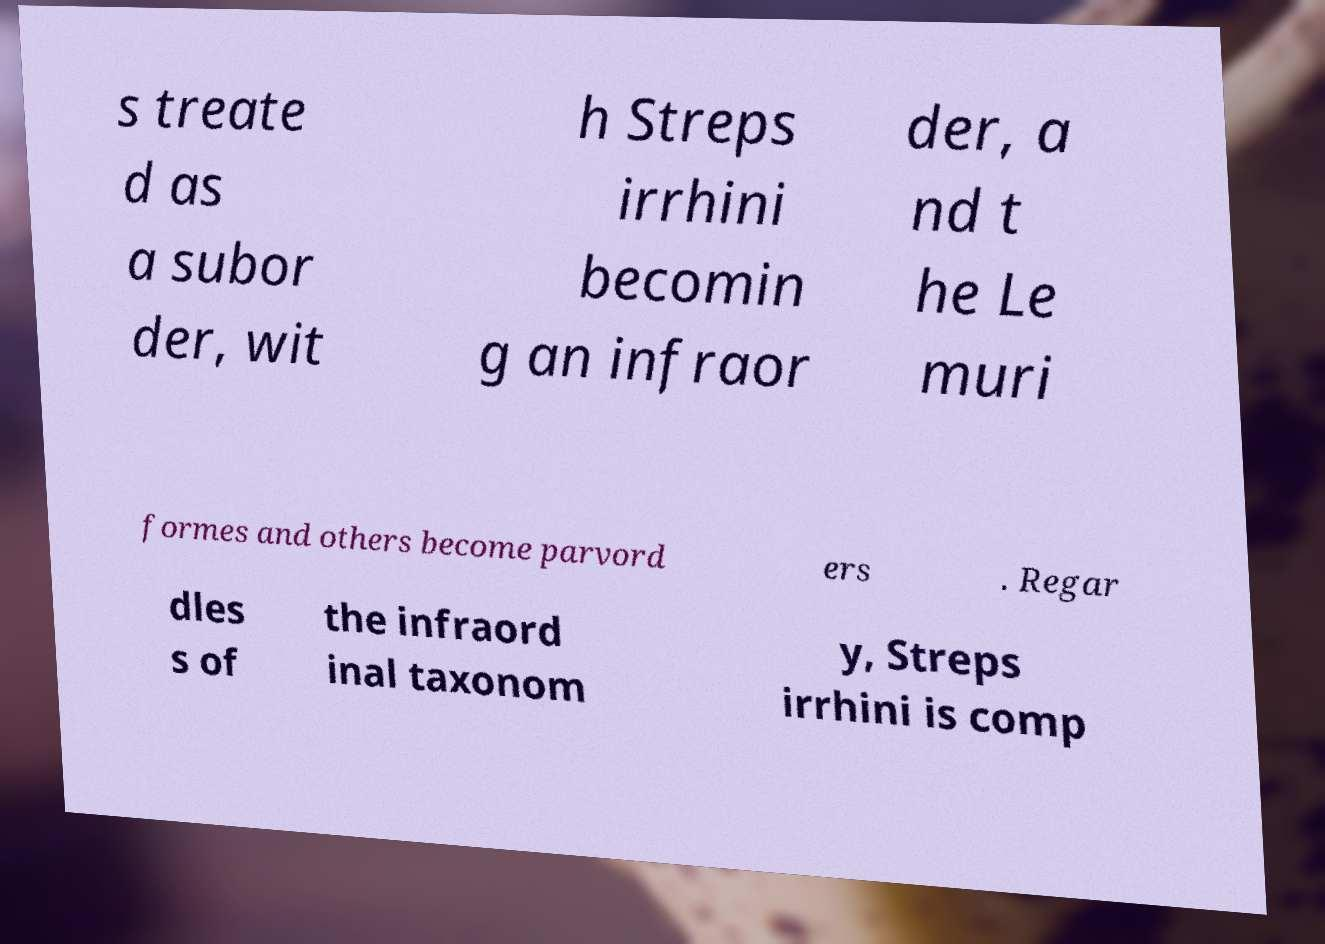What messages or text are displayed in this image? I need them in a readable, typed format. s treate d as a subor der, wit h Streps irrhini becomin g an infraor der, a nd t he Le muri formes and others become parvord ers . Regar dles s of the infraord inal taxonom y, Streps irrhini is comp 